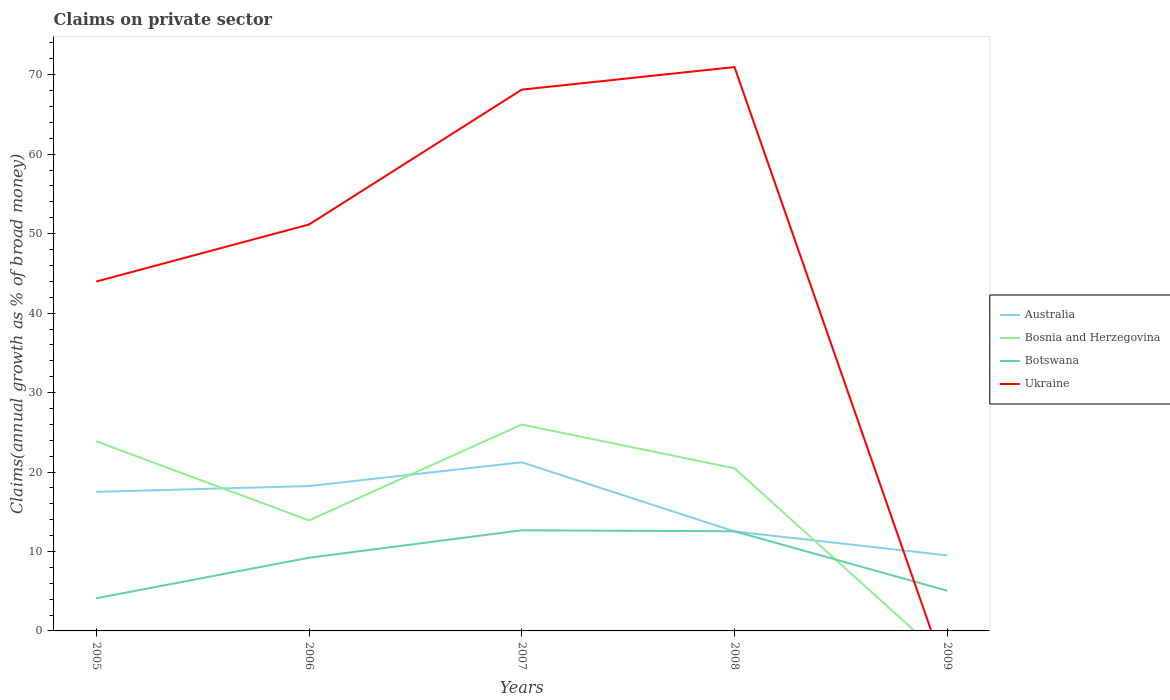How many different coloured lines are there?
Offer a very short reply. 4. Is the number of lines equal to the number of legend labels?
Your answer should be very brief. No. Across all years, what is the maximum percentage of broad money claimed on private sector in Botswana?
Keep it short and to the point. 4.11. What is the total percentage of broad money claimed on private sector in Botswana in the graph?
Give a very brief answer. 4.15. What is the difference between the highest and the second highest percentage of broad money claimed on private sector in Botswana?
Offer a terse response. 8.56. Is the percentage of broad money claimed on private sector in Botswana strictly greater than the percentage of broad money claimed on private sector in Bosnia and Herzegovina over the years?
Your answer should be compact. No. How many lines are there?
Offer a very short reply. 4. How many years are there in the graph?
Provide a succinct answer. 5. Are the values on the major ticks of Y-axis written in scientific E-notation?
Provide a short and direct response. No. Does the graph contain any zero values?
Your answer should be compact. Yes. Where does the legend appear in the graph?
Keep it short and to the point. Center right. How many legend labels are there?
Provide a short and direct response. 4. What is the title of the graph?
Your response must be concise. Claims on private sector. What is the label or title of the X-axis?
Your answer should be very brief. Years. What is the label or title of the Y-axis?
Your answer should be compact. Claims(annual growth as % of broad money). What is the Claims(annual growth as % of broad money) in Australia in 2005?
Ensure brevity in your answer.  17.5. What is the Claims(annual growth as % of broad money) of Bosnia and Herzegovina in 2005?
Provide a short and direct response. 23.87. What is the Claims(annual growth as % of broad money) in Botswana in 2005?
Your answer should be very brief. 4.11. What is the Claims(annual growth as % of broad money) of Ukraine in 2005?
Provide a succinct answer. 43.97. What is the Claims(annual growth as % of broad money) of Australia in 2006?
Provide a short and direct response. 18.23. What is the Claims(annual growth as % of broad money) in Bosnia and Herzegovina in 2006?
Keep it short and to the point. 13.91. What is the Claims(annual growth as % of broad money) of Botswana in 2006?
Offer a very short reply. 9.21. What is the Claims(annual growth as % of broad money) in Ukraine in 2006?
Provide a short and direct response. 51.15. What is the Claims(annual growth as % of broad money) of Australia in 2007?
Provide a short and direct response. 21.22. What is the Claims(annual growth as % of broad money) in Bosnia and Herzegovina in 2007?
Keep it short and to the point. 25.98. What is the Claims(annual growth as % of broad money) of Botswana in 2007?
Ensure brevity in your answer.  12.67. What is the Claims(annual growth as % of broad money) of Ukraine in 2007?
Your response must be concise. 68.12. What is the Claims(annual growth as % of broad money) of Australia in 2008?
Your answer should be compact. 12.52. What is the Claims(annual growth as % of broad money) of Bosnia and Herzegovina in 2008?
Make the answer very short. 20.47. What is the Claims(annual growth as % of broad money) in Botswana in 2008?
Offer a terse response. 12.54. What is the Claims(annual growth as % of broad money) in Ukraine in 2008?
Offer a terse response. 70.97. What is the Claims(annual growth as % of broad money) in Australia in 2009?
Offer a terse response. 9.51. What is the Claims(annual growth as % of broad money) in Botswana in 2009?
Keep it short and to the point. 5.06. Across all years, what is the maximum Claims(annual growth as % of broad money) of Australia?
Offer a very short reply. 21.22. Across all years, what is the maximum Claims(annual growth as % of broad money) of Bosnia and Herzegovina?
Your response must be concise. 25.98. Across all years, what is the maximum Claims(annual growth as % of broad money) in Botswana?
Keep it short and to the point. 12.67. Across all years, what is the maximum Claims(annual growth as % of broad money) in Ukraine?
Keep it short and to the point. 70.97. Across all years, what is the minimum Claims(annual growth as % of broad money) of Australia?
Provide a succinct answer. 9.51. Across all years, what is the minimum Claims(annual growth as % of broad money) in Bosnia and Herzegovina?
Offer a very short reply. 0. Across all years, what is the minimum Claims(annual growth as % of broad money) of Botswana?
Ensure brevity in your answer.  4.11. Across all years, what is the minimum Claims(annual growth as % of broad money) in Ukraine?
Your answer should be very brief. 0. What is the total Claims(annual growth as % of broad money) in Australia in the graph?
Make the answer very short. 78.99. What is the total Claims(annual growth as % of broad money) in Bosnia and Herzegovina in the graph?
Give a very brief answer. 84.22. What is the total Claims(annual growth as % of broad money) of Botswana in the graph?
Your response must be concise. 43.58. What is the total Claims(annual growth as % of broad money) in Ukraine in the graph?
Your answer should be very brief. 234.22. What is the difference between the Claims(annual growth as % of broad money) of Australia in 2005 and that in 2006?
Offer a terse response. -0.73. What is the difference between the Claims(annual growth as % of broad money) in Bosnia and Herzegovina in 2005 and that in 2006?
Offer a very short reply. 9.96. What is the difference between the Claims(annual growth as % of broad money) in Botswana in 2005 and that in 2006?
Give a very brief answer. -5.11. What is the difference between the Claims(annual growth as % of broad money) in Ukraine in 2005 and that in 2006?
Provide a short and direct response. -7.17. What is the difference between the Claims(annual growth as % of broad money) of Australia in 2005 and that in 2007?
Provide a succinct answer. -3.72. What is the difference between the Claims(annual growth as % of broad money) of Bosnia and Herzegovina in 2005 and that in 2007?
Your response must be concise. -2.11. What is the difference between the Claims(annual growth as % of broad money) in Botswana in 2005 and that in 2007?
Give a very brief answer. -8.56. What is the difference between the Claims(annual growth as % of broad money) of Ukraine in 2005 and that in 2007?
Your answer should be very brief. -24.15. What is the difference between the Claims(annual growth as % of broad money) of Australia in 2005 and that in 2008?
Offer a very short reply. 4.98. What is the difference between the Claims(annual growth as % of broad money) of Bosnia and Herzegovina in 2005 and that in 2008?
Ensure brevity in your answer.  3.4. What is the difference between the Claims(annual growth as % of broad money) in Botswana in 2005 and that in 2008?
Provide a short and direct response. -8.43. What is the difference between the Claims(annual growth as % of broad money) in Ukraine in 2005 and that in 2008?
Make the answer very short. -26.99. What is the difference between the Claims(annual growth as % of broad money) of Australia in 2005 and that in 2009?
Your answer should be compact. 8. What is the difference between the Claims(annual growth as % of broad money) of Botswana in 2005 and that in 2009?
Your response must be concise. -0.95. What is the difference between the Claims(annual growth as % of broad money) in Australia in 2006 and that in 2007?
Offer a terse response. -2.99. What is the difference between the Claims(annual growth as % of broad money) of Bosnia and Herzegovina in 2006 and that in 2007?
Ensure brevity in your answer.  -12.06. What is the difference between the Claims(annual growth as % of broad money) in Botswana in 2006 and that in 2007?
Make the answer very short. -3.45. What is the difference between the Claims(annual growth as % of broad money) in Ukraine in 2006 and that in 2007?
Provide a short and direct response. -16.97. What is the difference between the Claims(annual growth as % of broad money) in Australia in 2006 and that in 2008?
Make the answer very short. 5.71. What is the difference between the Claims(annual growth as % of broad money) of Bosnia and Herzegovina in 2006 and that in 2008?
Provide a short and direct response. -6.56. What is the difference between the Claims(annual growth as % of broad money) in Botswana in 2006 and that in 2008?
Provide a short and direct response. -3.32. What is the difference between the Claims(annual growth as % of broad money) of Ukraine in 2006 and that in 2008?
Your answer should be compact. -19.82. What is the difference between the Claims(annual growth as % of broad money) in Australia in 2006 and that in 2009?
Give a very brief answer. 8.73. What is the difference between the Claims(annual growth as % of broad money) of Botswana in 2006 and that in 2009?
Offer a terse response. 4.15. What is the difference between the Claims(annual growth as % of broad money) of Australia in 2007 and that in 2008?
Provide a short and direct response. 8.7. What is the difference between the Claims(annual growth as % of broad money) of Bosnia and Herzegovina in 2007 and that in 2008?
Provide a short and direct response. 5.51. What is the difference between the Claims(annual growth as % of broad money) of Botswana in 2007 and that in 2008?
Provide a short and direct response. 0.13. What is the difference between the Claims(annual growth as % of broad money) in Ukraine in 2007 and that in 2008?
Offer a terse response. -2.84. What is the difference between the Claims(annual growth as % of broad money) of Australia in 2007 and that in 2009?
Provide a succinct answer. 11.72. What is the difference between the Claims(annual growth as % of broad money) of Botswana in 2007 and that in 2009?
Your response must be concise. 7.61. What is the difference between the Claims(annual growth as % of broad money) in Australia in 2008 and that in 2009?
Your response must be concise. 3.01. What is the difference between the Claims(annual growth as % of broad money) in Botswana in 2008 and that in 2009?
Provide a succinct answer. 7.47. What is the difference between the Claims(annual growth as % of broad money) of Australia in 2005 and the Claims(annual growth as % of broad money) of Bosnia and Herzegovina in 2006?
Provide a succinct answer. 3.59. What is the difference between the Claims(annual growth as % of broad money) in Australia in 2005 and the Claims(annual growth as % of broad money) in Botswana in 2006?
Offer a terse response. 8.29. What is the difference between the Claims(annual growth as % of broad money) of Australia in 2005 and the Claims(annual growth as % of broad money) of Ukraine in 2006?
Your answer should be very brief. -33.65. What is the difference between the Claims(annual growth as % of broad money) in Bosnia and Herzegovina in 2005 and the Claims(annual growth as % of broad money) in Botswana in 2006?
Ensure brevity in your answer.  14.65. What is the difference between the Claims(annual growth as % of broad money) in Bosnia and Herzegovina in 2005 and the Claims(annual growth as % of broad money) in Ukraine in 2006?
Offer a very short reply. -27.28. What is the difference between the Claims(annual growth as % of broad money) of Botswana in 2005 and the Claims(annual growth as % of broad money) of Ukraine in 2006?
Provide a succinct answer. -47.04. What is the difference between the Claims(annual growth as % of broad money) of Australia in 2005 and the Claims(annual growth as % of broad money) of Bosnia and Herzegovina in 2007?
Offer a terse response. -8.47. What is the difference between the Claims(annual growth as % of broad money) in Australia in 2005 and the Claims(annual growth as % of broad money) in Botswana in 2007?
Keep it short and to the point. 4.84. What is the difference between the Claims(annual growth as % of broad money) of Australia in 2005 and the Claims(annual growth as % of broad money) of Ukraine in 2007?
Your response must be concise. -50.62. What is the difference between the Claims(annual growth as % of broad money) in Bosnia and Herzegovina in 2005 and the Claims(annual growth as % of broad money) in Botswana in 2007?
Your answer should be very brief. 11.2. What is the difference between the Claims(annual growth as % of broad money) in Bosnia and Herzegovina in 2005 and the Claims(annual growth as % of broad money) in Ukraine in 2007?
Ensure brevity in your answer.  -44.26. What is the difference between the Claims(annual growth as % of broad money) of Botswana in 2005 and the Claims(annual growth as % of broad money) of Ukraine in 2007?
Ensure brevity in your answer.  -64.02. What is the difference between the Claims(annual growth as % of broad money) in Australia in 2005 and the Claims(annual growth as % of broad money) in Bosnia and Herzegovina in 2008?
Ensure brevity in your answer.  -2.96. What is the difference between the Claims(annual growth as % of broad money) in Australia in 2005 and the Claims(annual growth as % of broad money) in Botswana in 2008?
Ensure brevity in your answer.  4.97. What is the difference between the Claims(annual growth as % of broad money) in Australia in 2005 and the Claims(annual growth as % of broad money) in Ukraine in 2008?
Offer a terse response. -53.47. What is the difference between the Claims(annual growth as % of broad money) of Bosnia and Herzegovina in 2005 and the Claims(annual growth as % of broad money) of Botswana in 2008?
Your answer should be very brief. 11.33. What is the difference between the Claims(annual growth as % of broad money) of Bosnia and Herzegovina in 2005 and the Claims(annual growth as % of broad money) of Ukraine in 2008?
Give a very brief answer. -47.1. What is the difference between the Claims(annual growth as % of broad money) of Botswana in 2005 and the Claims(annual growth as % of broad money) of Ukraine in 2008?
Offer a terse response. -66.86. What is the difference between the Claims(annual growth as % of broad money) in Australia in 2005 and the Claims(annual growth as % of broad money) in Botswana in 2009?
Your answer should be compact. 12.44. What is the difference between the Claims(annual growth as % of broad money) in Bosnia and Herzegovina in 2005 and the Claims(annual growth as % of broad money) in Botswana in 2009?
Offer a terse response. 18.81. What is the difference between the Claims(annual growth as % of broad money) in Australia in 2006 and the Claims(annual growth as % of broad money) in Bosnia and Herzegovina in 2007?
Your answer should be compact. -7.74. What is the difference between the Claims(annual growth as % of broad money) of Australia in 2006 and the Claims(annual growth as % of broad money) of Botswana in 2007?
Give a very brief answer. 5.57. What is the difference between the Claims(annual growth as % of broad money) of Australia in 2006 and the Claims(annual growth as % of broad money) of Ukraine in 2007?
Offer a very short reply. -49.89. What is the difference between the Claims(annual growth as % of broad money) in Bosnia and Herzegovina in 2006 and the Claims(annual growth as % of broad money) in Botswana in 2007?
Your answer should be very brief. 1.24. What is the difference between the Claims(annual growth as % of broad money) of Bosnia and Herzegovina in 2006 and the Claims(annual growth as % of broad money) of Ukraine in 2007?
Ensure brevity in your answer.  -54.21. What is the difference between the Claims(annual growth as % of broad money) of Botswana in 2006 and the Claims(annual growth as % of broad money) of Ukraine in 2007?
Make the answer very short. -58.91. What is the difference between the Claims(annual growth as % of broad money) of Australia in 2006 and the Claims(annual growth as % of broad money) of Bosnia and Herzegovina in 2008?
Offer a very short reply. -2.23. What is the difference between the Claims(annual growth as % of broad money) of Australia in 2006 and the Claims(annual growth as % of broad money) of Botswana in 2008?
Offer a very short reply. 5.7. What is the difference between the Claims(annual growth as % of broad money) of Australia in 2006 and the Claims(annual growth as % of broad money) of Ukraine in 2008?
Your response must be concise. -52.73. What is the difference between the Claims(annual growth as % of broad money) of Bosnia and Herzegovina in 2006 and the Claims(annual growth as % of broad money) of Botswana in 2008?
Give a very brief answer. 1.37. What is the difference between the Claims(annual growth as % of broad money) of Bosnia and Herzegovina in 2006 and the Claims(annual growth as % of broad money) of Ukraine in 2008?
Keep it short and to the point. -57.06. What is the difference between the Claims(annual growth as % of broad money) of Botswana in 2006 and the Claims(annual growth as % of broad money) of Ukraine in 2008?
Make the answer very short. -61.76. What is the difference between the Claims(annual growth as % of broad money) of Australia in 2006 and the Claims(annual growth as % of broad money) of Botswana in 2009?
Keep it short and to the point. 13.17. What is the difference between the Claims(annual growth as % of broad money) of Bosnia and Herzegovina in 2006 and the Claims(annual growth as % of broad money) of Botswana in 2009?
Provide a short and direct response. 8.85. What is the difference between the Claims(annual growth as % of broad money) of Australia in 2007 and the Claims(annual growth as % of broad money) of Bosnia and Herzegovina in 2008?
Offer a terse response. 0.76. What is the difference between the Claims(annual growth as % of broad money) of Australia in 2007 and the Claims(annual growth as % of broad money) of Botswana in 2008?
Your answer should be very brief. 8.69. What is the difference between the Claims(annual growth as % of broad money) of Australia in 2007 and the Claims(annual growth as % of broad money) of Ukraine in 2008?
Offer a very short reply. -49.75. What is the difference between the Claims(annual growth as % of broad money) in Bosnia and Herzegovina in 2007 and the Claims(annual growth as % of broad money) in Botswana in 2008?
Provide a short and direct response. 13.44. What is the difference between the Claims(annual growth as % of broad money) in Bosnia and Herzegovina in 2007 and the Claims(annual growth as % of broad money) in Ukraine in 2008?
Offer a very short reply. -44.99. What is the difference between the Claims(annual growth as % of broad money) in Botswana in 2007 and the Claims(annual growth as % of broad money) in Ukraine in 2008?
Your answer should be very brief. -58.3. What is the difference between the Claims(annual growth as % of broad money) in Australia in 2007 and the Claims(annual growth as % of broad money) in Botswana in 2009?
Your answer should be compact. 16.16. What is the difference between the Claims(annual growth as % of broad money) of Bosnia and Herzegovina in 2007 and the Claims(annual growth as % of broad money) of Botswana in 2009?
Offer a terse response. 20.91. What is the difference between the Claims(annual growth as % of broad money) in Australia in 2008 and the Claims(annual growth as % of broad money) in Botswana in 2009?
Offer a very short reply. 7.46. What is the difference between the Claims(annual growth as % of broad money) of Bosnia and Herzegovina in 2008 and the Claims(annual growth as % of broad money) of Botswana in 2009?
Provide a short and direct response. 15.41. What is the average Claims(annual growth as % of broad money) of Australia per year?
Your answer should be very brief. 15.8. What is the average Claims(annual growth as % of broad money) in Bosnia and Herzegovina per year?
Your answer should be very brief. 16.84. What is the average Claims(annual growth as % of broad money) of Botswana per year?
Offer a terse response. 8.72. What is the average Claims(annual growth as % of broad money) of Ukraine per year?
Make the answer very short. 46.84. In the year 2005, what is the difference between the Claims(annual growth as % of broad money) in Australia and Claims(annual growth as % of broad money) in Bosnia and Herzegovina?
Your answer should be compact. -6.36. In the year 2005, what is the difference between the Claims(annual growth as % of broad money) in Australia and Claims(annual growth as % of broad money) in Botswana?
Provide a short and direct response. 13.4. In the year 2005, what is the difference between the Claims(annual growth as % of broad money) of Australia and Claims(annual growth as % of broad money) of Ukraine?
Offer a very short reply. -26.47. In the year 2005, what is the difference between the Claims(annual growth as % of broad money) of Bosnia and Herzegovina and Claims(annual growth as % of broad money) of Botswana?
Give a very brief answer. 19.76. In the year 2005, what is the difference between the Claims(annual growth as % of broad money) of Bosnia and Herzegovina and Claims(annual growth as % of broad money) of Ukraine?
Provide a succinct answer. -20.11. In the year 2005, what is the difference between the Claims(annual growth as % of broad money) in Botswana and Claims(annual growth as % of broad money) in Ukraine?
Make the answer very short. -39.87. In the year 2006, what is the difference between the Claims(annual growth as % of broad money) of Australia and Claims(annual growth as % of broad money) of Bosnia and Herzegovina?
Your answer should be very brief. 4.32. In the year 2006, what is the difference between the Claims(annual growth as % of broad money) of Australia and Claims(annual growth as % of broad money) of Botswana?
Your answer should be compact. 9.02. In the year 2006, what is the difference between the Claims(annual growth as % of broad money) in Australia and Claims(annual growth as % of broad money) in Ukraine?
Give a very brief answer. -32.92. In the year 2006, what is the difference between the Claims(annual growth as % of broad money) in Bosnia and Herzegovina and Claims(annual growth as % of broad money) in Botswana?
Provide a succinct answer. 4.7. In the year 2006, what is the difference between the Claims(annual growth as % of broad money) of Bosnia and Herzegovina and Claims(annual growth as % of broad money) of Ukraine?
Give a very brief answer. -37.24. In the year 2006, what is the difference between the Claims(annual growth as % of broad money) in Botswana and Claims(annual growth as % of broad money) in Ukraine?
Ensure brevity in your answer.  -41.94. In the year 2007, what is the difference between the Claims(annual growth as % of broad money) in Australia and Claims(annual growth as % of broad money) in Bosnia and Herzegovina?
Your response must be concise. -4.75. In the year 2007, what is the difference between the Claims(annual growth as % of broad money) in Australia and Claims(annual growth as % of broad money) in Botswana?
Provide a short and direct response. 8.56. In the year 2007, what is the difference between the Claims(annual growth as % of broad money) in Australia and Claims(annual growth as % of broad money) in Ukraine?
Your answer should be compact. -46.9. In the year 2007, what is the difference between the Claims(annual growth as % of broad money) in Bosnia and Herzegovina and Claims(annual growth as % of broad money) in Botswana?
Provide a short and direct response. 13.31. In the year 2007, what is the difference between the Claims(annual growth as % of broad money) of Bosnia and Herzegovina and Claims(annual growth as % of broad money) of Ukraine?
Provide a short and direct response. -42.15. In the year 2007, what is the difference between the Claims(annual growth as % of broad money) of Botswana and Claims(annual growth as % of broad money) of Ukraine?
Offer a terse response. -55.46. In the year 2008, what is the difference between the Claims(annual growth as % of broad money) of Australia and Claims(annual growth as % of broad money) of Bosnia and Herzegovina?
Give a very brief answer. -7.95. In the year 2008, what is the difference between the Claims(annual growth as % of broad money) in Australia and Claims(annual growth as % of broad money) in Botswana?
Provide a succinct answer. -0.01. In the year 2008, what is the difference between the Claims(annual growth as % of broad money) in Australia and Claims(annual growth as % of broad money) in Ukraine?
Offer a very short reply. -58.45. In the year 2008, what is the difference between the Claims(annual growth as % of broad money) in Bosnia and Herzegovina and Claims(annual growth as % of broad money) in Botswana?
Offer a terse response. 7.93. In the year 2008, what is the difference between the Claims(annual growth as % of broad money) in Bosnia and Herzegovina and Claims(annual growth as % of broad money) in Ukraine?
Your answer should be very brief. -50.5. In the year 2008, what is the difference between the Claims(annual growth as % of broad money) in Botswana and Claims(annual growth as % of broad money) in Ukraine?
Ensure brevity in your answer.  -58.43. In the year 2009, what is the difference between the Claims(annual growth as % of broad money) in Australia and Claims(annual growth as % of broad money) in Botswana?
Your answer should be very brief. 4.45. What is the ratio of the Claims(annual growth as % of broad money) in Australia in 2005 to that in 2006?
Give a very brief answer. 0.96. What is the ratio of the Claims(annual growth as % of broad money) in Bosnia and Herzegovina in 2005 to that in 2006?
Your response must be concise. 1.72. What is the ratio of the Claims(annual growth as % of broad money) in Botswana in 2005 to that in 2006?
Provide a succinct answer. 0.45. What is the ratio of the Claims(annual growth as % of broad money) in Ukraine in 2005 to that in 2006?
Provide a succinct answer. 0.86. What is the ratio of the Claims(annual growth as % of broad money) of Australia in 2005 to that in 2007?
Ensure brevity in your answer.  0.82. What is the ratio of the Claims(annual growth as % of broad money) in Bosnia and Herzegovina in 2005 to that in 2007?
Your answer should be compact. 0.92. What is the ratio of the Claims(annual growth as % of broad money) of Botswana in 2005 to that in 2007?
Ensure brevity in your answer.  0.32. What is the ratio of the Claims(annual growth as % of broad money) in Ukraine in 2005 to that in 2007?
Provide a succinct answer. 0.65. What is the ratio of the Claims(annual growth as % of broad money) of Australia in 2005 to that in 2008?
Your answer should be very brief. 1.4. What is the ratio of the Claims(annual growth as % of broad money) of Bosnia and Herzegovina in 2005 to that in 2008?
Keep it short and to the point. 1.17. What is the ratio of the Claims(annual growth as % of broad money) of Botswana in 2005 to that in 2008?
Make the answer very short. 0.33. What is the ratio of the Claims(annual growth as % of broad money) in Ukraine in 2005 to that in 2008?
Provide a short and direct response. 0.62. What is the ratio of the Claims(annual growth as % of broad money) of Australia in 2005 to that in 2009?
Provide a succinct answer. 1.84. What is the ratio of the Claims(annual growth as % of broad money) in Botswana in 2005 to that in 2009?
Your answer should be compact. 0.81. What is the ratio of the Claims(annual growth as % of broad money) of Australia in 2006 to that in 2007?
Your answer should be compact. 0.86. What is the ratio of the Claims(annual growth as % of broad money) in Bosnia and Herzegovina in 2006 to that in 2007?
Provide a succinct answer. 0.54. What is the ratio of the Claims(annual growth as % of broad money) in Botswana in 2006 to that in 2007?
Offer a very short reply. 0.73. What is the ratio of the Claims(annual growth as % of broad money) in Ukraine in 2006 to that in 2007?
Provide a short and direct response. 0.75. What is the ratio of the Claims(annual growth as % of broad money) in Australia in 2006 to that in 2008?
Keep it short and to the point. 1.46. What is the ratio of the Claims(annual growth as % of broad money) of Bosnia and Herzegovina in 2006 to that in 2008?
Your response must be concise. 0.68. What is the ratio of the Claims(annual growth as % of broad money) of Botswana in 2006 to that in 2008?
Your answer should be compact. 0.73. What is the ratio of the Claims(annual growth as % of broad money) in Ukraine in 2006 to that in 2008?
Provide a succinct answer. 0.72. What is the ratio of the Claims(annual growth as % of broad money) of Australia in 2006 to that in 2009?
Your answer should be very brief. 1.92. What is the ratio of the Claims(annual growth as % of broad money) in Botswana in 2006 to that in 2009?
Make the answer very short. 1.82. What is the ratio of the Claims(annual growth as % of broad money) in Australia in 2007 to that in 2008?
Provide a short and direct response. 1.7. What is the ratio of the Claims(annual growth as % of broad money) of Bosnia and Herzegovina in 2007 to that in 2008?
Provide a short and direct response. 1.27. What is the ratio of the Claims(annual growth as % of broad money) in Botswana in 2007 to that in 2008?
Your answer should be very brief. 1.01. What is the ratio of the Claims(annual growth as % of broad money) of Ukraine in 2007 to that in 2008?
Offer a very short reply. 0.96. What is the ratio of the Claims(annual growth as % of broad money) in Australia in 2007 to that in 2009?
Your answer should be compact. 2.23. What is the ratio of the Claims(annual growth as % of broad money) of Botswana in 2007 to that in 2009?
Provide a succinct answer. 2.5. What is the ratio of the Claims(annual growth as % of broad money) of Australia in 2008 to that in 2009?
Your answer should be very brief. 1.32. What is the ratio of the Claims(annual growth as % of broad money) in Botswana in 2008 to that in 2009?
Ensure brevity in your answer.  2.48. What is the difference between the highest and the second highest Claims(annual growth as % of broad money) in Australia?
Ensure brevity in your answer.  2.99. What is the difference between the highest and the second highest Claims(annual growth as % of broad money) in Bosnia and Herzegovina?
Give a very brief answer. 2.11. What is the difference between the highest and the second highest Claims(annual growth as % of broad money) of Botswana?
Give a very brief answer. 0.13. What is the difference between the highest and the second highest Claims(annual growth as % of broad money) of Ukraine?
Make the answer very short. 2.84. What is the difference between the highest and the lowest Claims(annual growth as % of broad money) in Australia?
Ensure brevity in your answer.  11.72. What is the difference between the highest and the lowest Claims(annual growth as % of broad money) of Bosnia and Herzegovina?
Keep it short and to the point. 25.98. What is the difference between the highest and the lowest Claims(annual growth as % of broad money) of Botswana?
Keep it short and to the point. 8.56. What is the difference between the highest and the lowest Claims(annual growth as % of broad money) in Ukraine?
Provide a short and direct response. 70.97. 